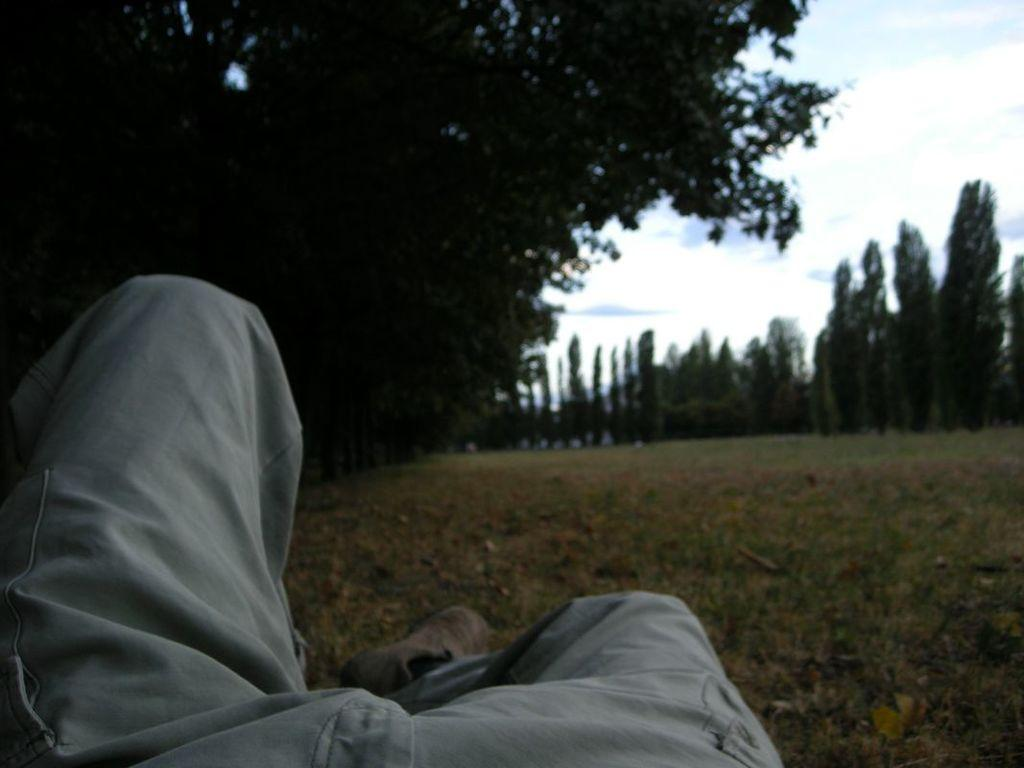What part of a person can be seen in the image? There are legs of a person visible in the image. What type of terrain is present in the image? There is grass visible in the image. What type of vegetation is present in the image? There is a group of trees in the image. What is the condition of the sky in the image? The sky is visible in the image and appears cloudy. How many loaves are present in the image? There are no loaves present in the image. 